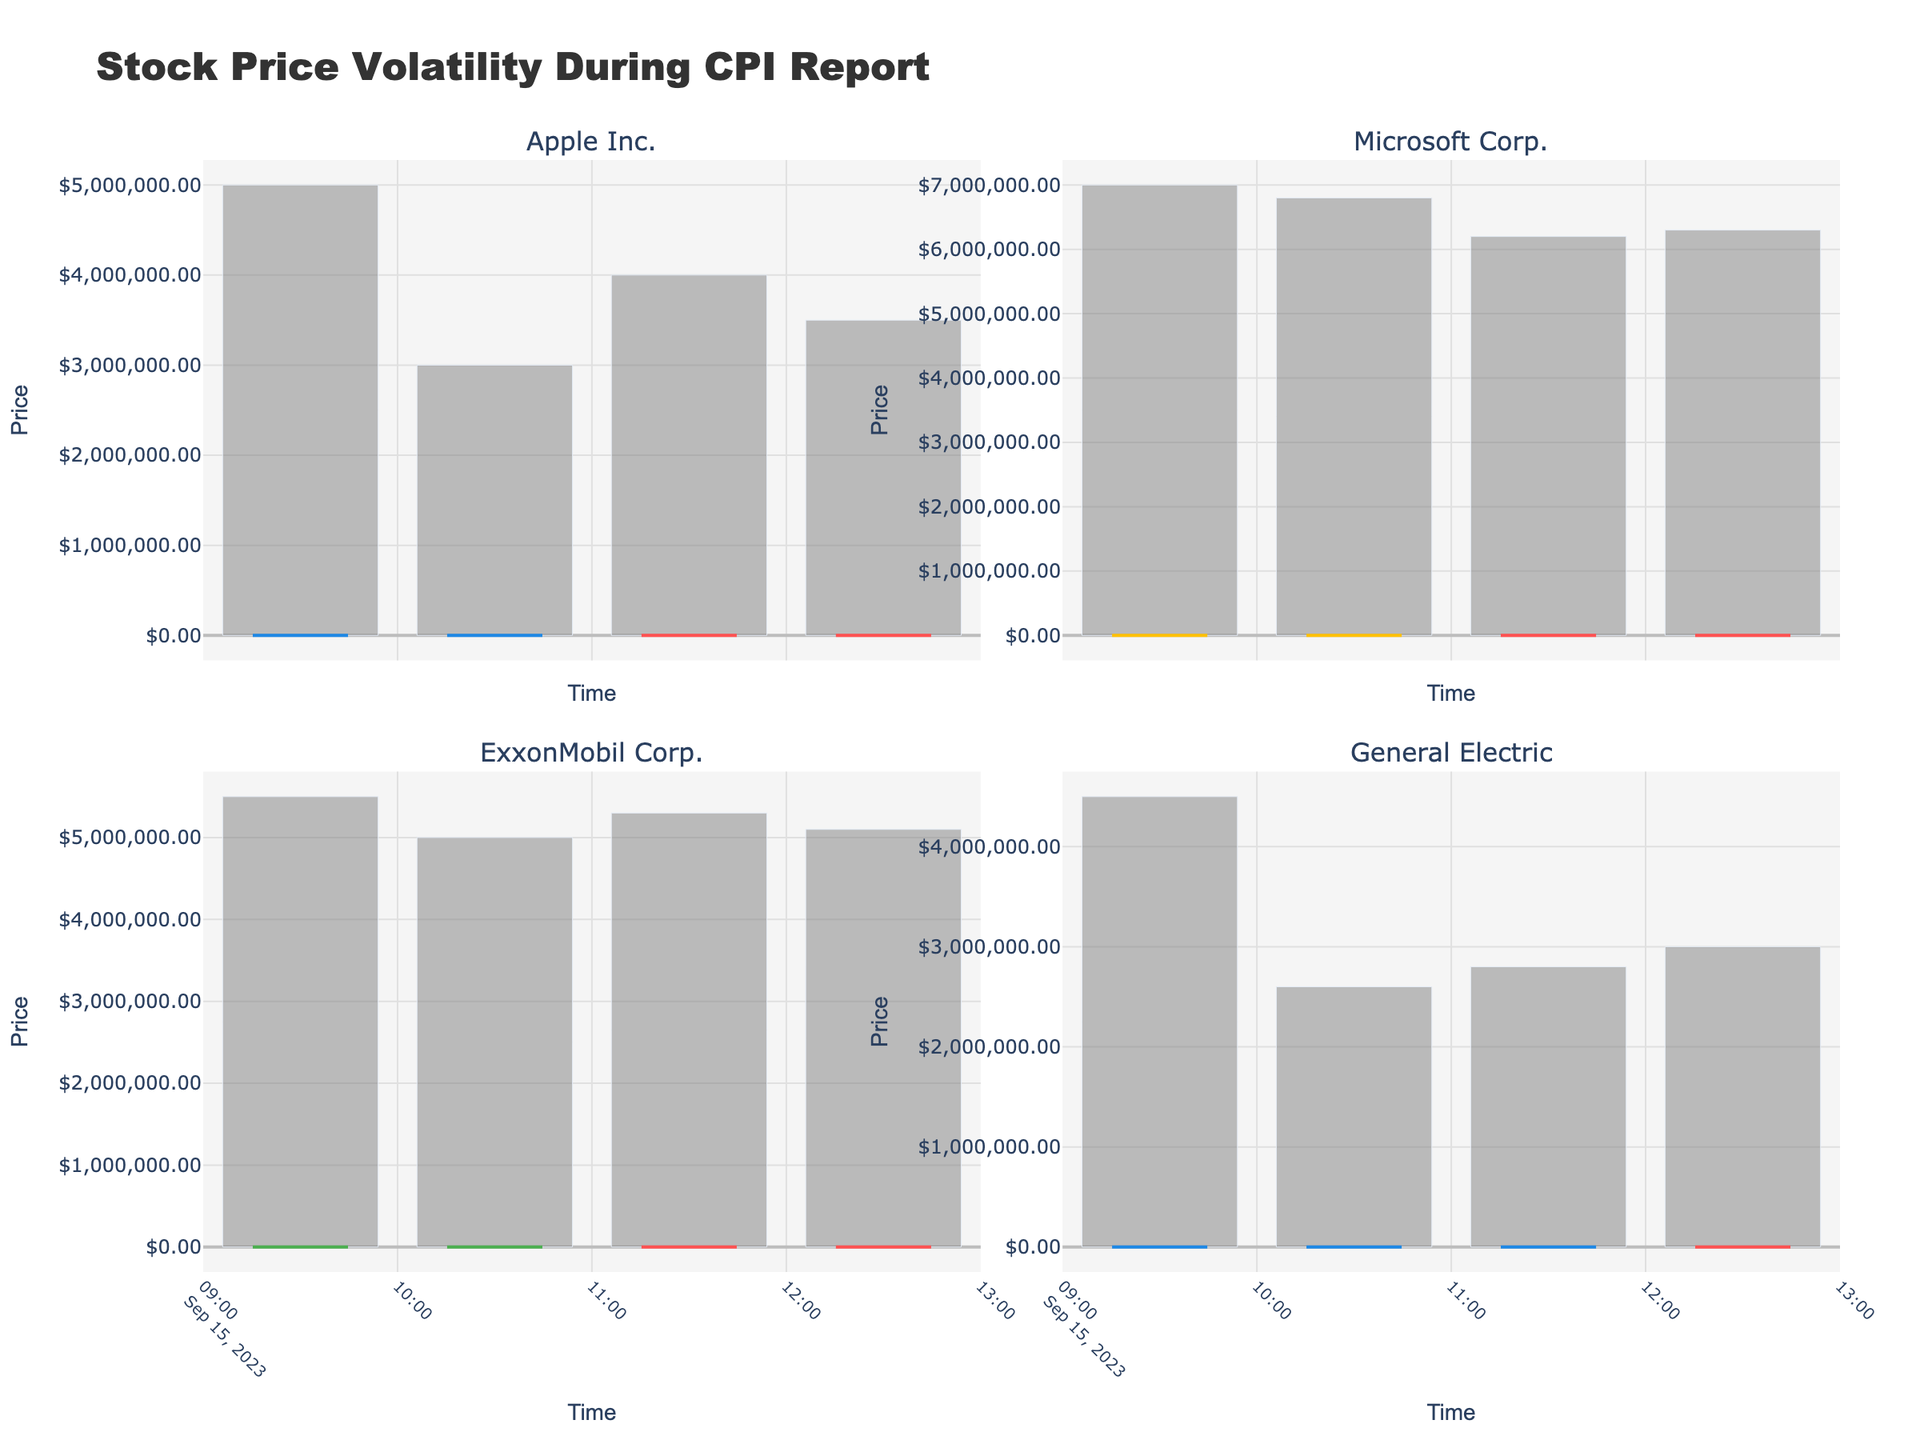What sectors are represented in the figure? The subplot titles represent different companies belonging to various sectors. By examining these titles and color keys, we can identify the sectors represented. The colors #1E88E5, #FFC107, and #4CAF50 correspond to Technology, Energy, and Industrial sectors respectively.
Answer: Technology, Energy, Industrial Which company's stock had the highest opening price at 09:30? By examining the opening prices for each company in their respective subplots at 09:30, the highest value should be selected. Apple Inc. has an opening price of $150, Microsoft Corp. $120, ExxonMobil Corp. $300, and General Electric $200. The highest opening price is for ExxonMobil Corp.
Answer: ExxonMobil Corp How did ExxonMobil's close price change from 09:30 to 12:30? For ExxonMobil Corp., the close price at 09:30 was $308, and at 12:30 it was $305. The change is calculated as $305 - $308
Answer: The closing price decreased by $3 Which sector experienced the highest volume at 10:30? Inspect the bar plots representing volumes at 10:30. Compare the volumes for each company and determine which sector had the highest amount: Apple Inc. (3M), Microsoft Corp. (2.6M), ExxonMobil Corp. (6.8M), General Electric (5M). ExxonMobil Corp., which belongs to the Energy sector, has the highest volume.
Answer: Energy How did General Electric's range of high and low prices at 12:30 compare to Apple Inc.'s? For General Electric, the high at 12:30 was $207, and the low was $200.50, thus the range is $206 - $200.50 = $6.50. For Apple Inc., the high was $154.50, and the low was $150.50, giving a range of $154.50 - $150.50 = $4.00. Compare both ranges.
Answer: General Electric's range is $2.50 greater than Apple Inc.'s Which company showed the greatest fluctuation in prices during the given time? Compute the range (High - Low) for each company throughout the data: Apple Inc. (157-148 = $9), Microsoft (128-118 = $10), ExxonMobil (315-295 = $20), General Electric (209-198 = $11). The company with the highest range indicates the greatest fluctuation.
Answer: ExxonMobil Corp Which company had the overall increasing trend in stock prices from 09:30 to 12:30? Observe the start and end prices in the candlestick plots of each company to check general trends. Apple Inc. started at $150 and ended at $151, Microsoft started at $120 and ended at $125, ExxonMobil started at $300 and ended at $305, General Electric started at $200 and ended at $203.
Answer: Microsoft Corp Among all companies, during which time interval was the highest price recorded? By inspecting the individual high points on each subplot, notice the times: Apple at 11:30 (157), Microsoft at 11:30 (128), ExxonMobil at 10:30 (315), General Electric at 11:30 (209). The highest price, $315, was recorded at ExxonMobil at 10:30.
Answer: 10:30 Which stock had the least variance in its closing prices across the given times? Calculate the variance for each company's closing prices: Apple Inc. ($154, $155, $153, $151), Microsoft ($124, $125.5, $126, $125), ExxonMobil ($308, $310, $306, $305), General Electric ($204, $207, $205, $203). The minimum variance can be determined using these figures.
Answer: Microsoft Corp How did the volume of trades in the Technology sector change from 09:30 to 12:30? Sum the volumes for both Apple Inc. and Microsoft Corp. at these times. At 09:30, the volumes for Apple (5M) and Microsoft (4.5M) combined are 9.5M; at 12:30 for Apple (3.5M) and Microsoft (3M) combined is 6.5M. Compare these sums.
Answer: The volume decreased by 3M 